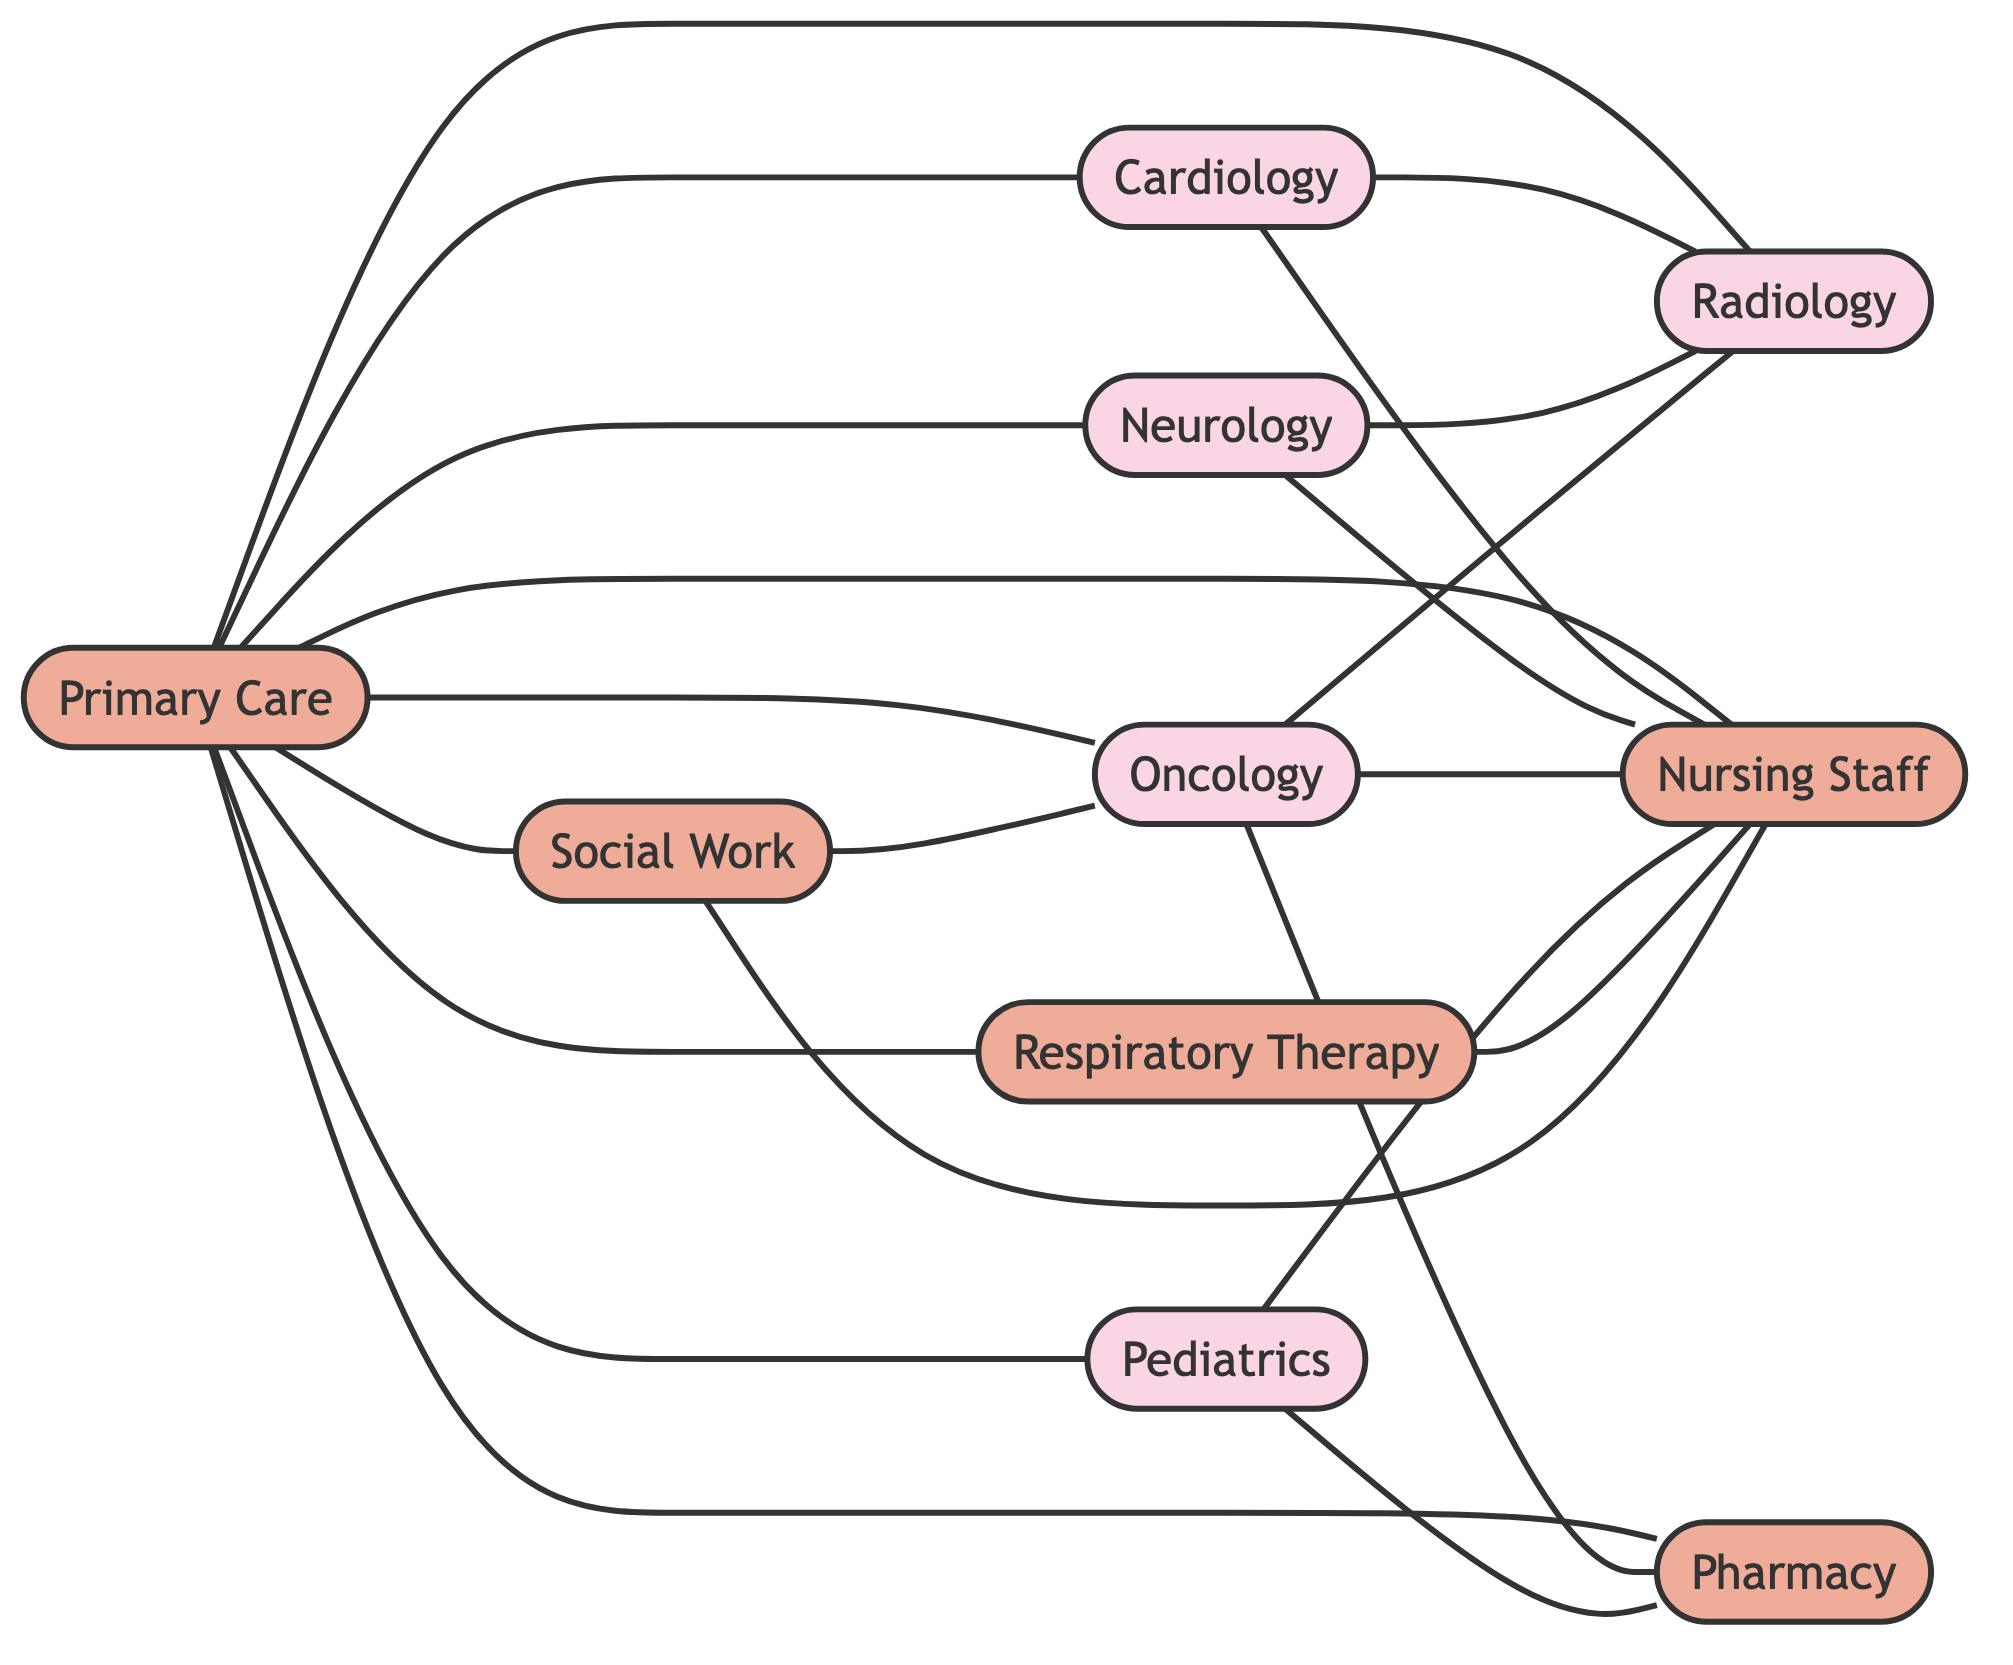What are the total number of departments represented in the diagram? The nodes labeled Cardiology, Neurology, Oncology, Pediatrics, and Radiology are identified as departments. Counting these, we find there are five department nodes.
Answer: five How many connections does the Primary Care department have? The Primary Care node connects to Cardiology, Neurology, Oncology, Pediatrics, Radiology, Nursing, Respiratory, Pharmacy, and Social Work. This accounts for a total of nine connections.
Answer: nine Which department collaborates with Oncology through Social Work? The Social Work node is directly connected to the Oncology node, indicating collaboration. Therefore, the department collaborating with Oncology is Social Work.
Answer: Social Work How many times does Nursing appear as a connecting point in the diagram? Nursing is connected to Primary Care, Cardiology, Neurology, Oncology, Pediatrics, Respiratory, and Social Work, resulting in a total of seven connections that involve Nursing.
Answer: seven Which department connects to both Pharmacy and Nursing? By examining the diagram, Oncology connects to both the Pharmacy and Nursing nodes directly, thereby fulfilling the criteria of connecting to both departments.
Answer: Oncology What is the relationship between Cardiology and Radiology? The Cardiology department has a direct edge connecting it to Radiology within the diagram, indicating a collaborative relationship between these two departments.
Answer: collaborative Identify one healthcare professional group that works exclusively with the Nursing department and does not directly connect to any departments. A single healthcare group that connects exclusively to Nursing without additional department connections is Respiratory Therapy, which connects only to Nursing.
Answer: Respiratory Therapy How many edges are connecting the department nodes to the service nodes? Counting the edges, we find that departments connect to service nodes a total of fifteen times throughout the diagram.
Answer: fifteen 